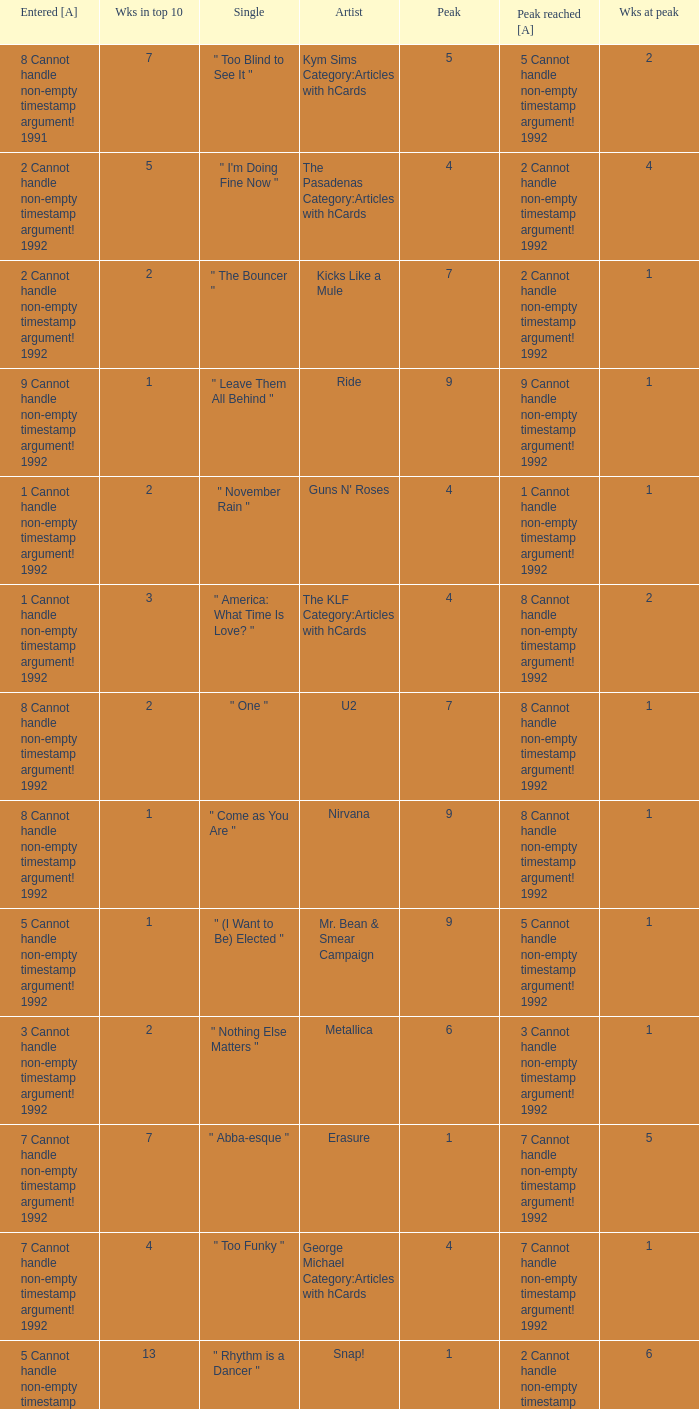If the peak is 9, how many weeks was it in the top 10? 1.0. 